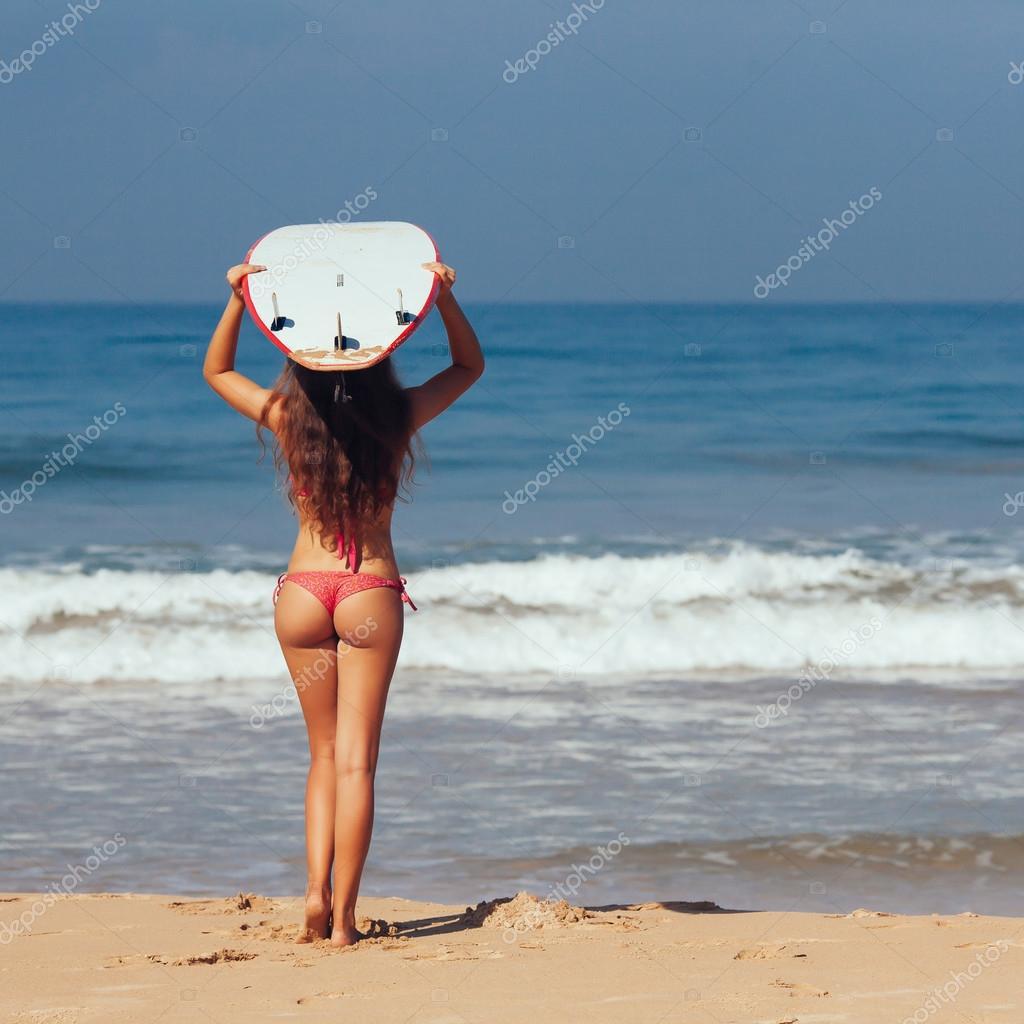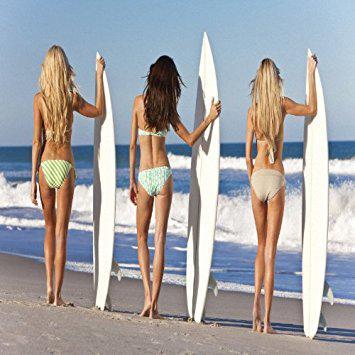The first image is the image on the left, the second image is the image on the right. Examine the images to the left and right. Is the description "An image shows just one bikini model facing the ocean and holding a surfboard on the right side." accurate? Answer yes or no. No. 